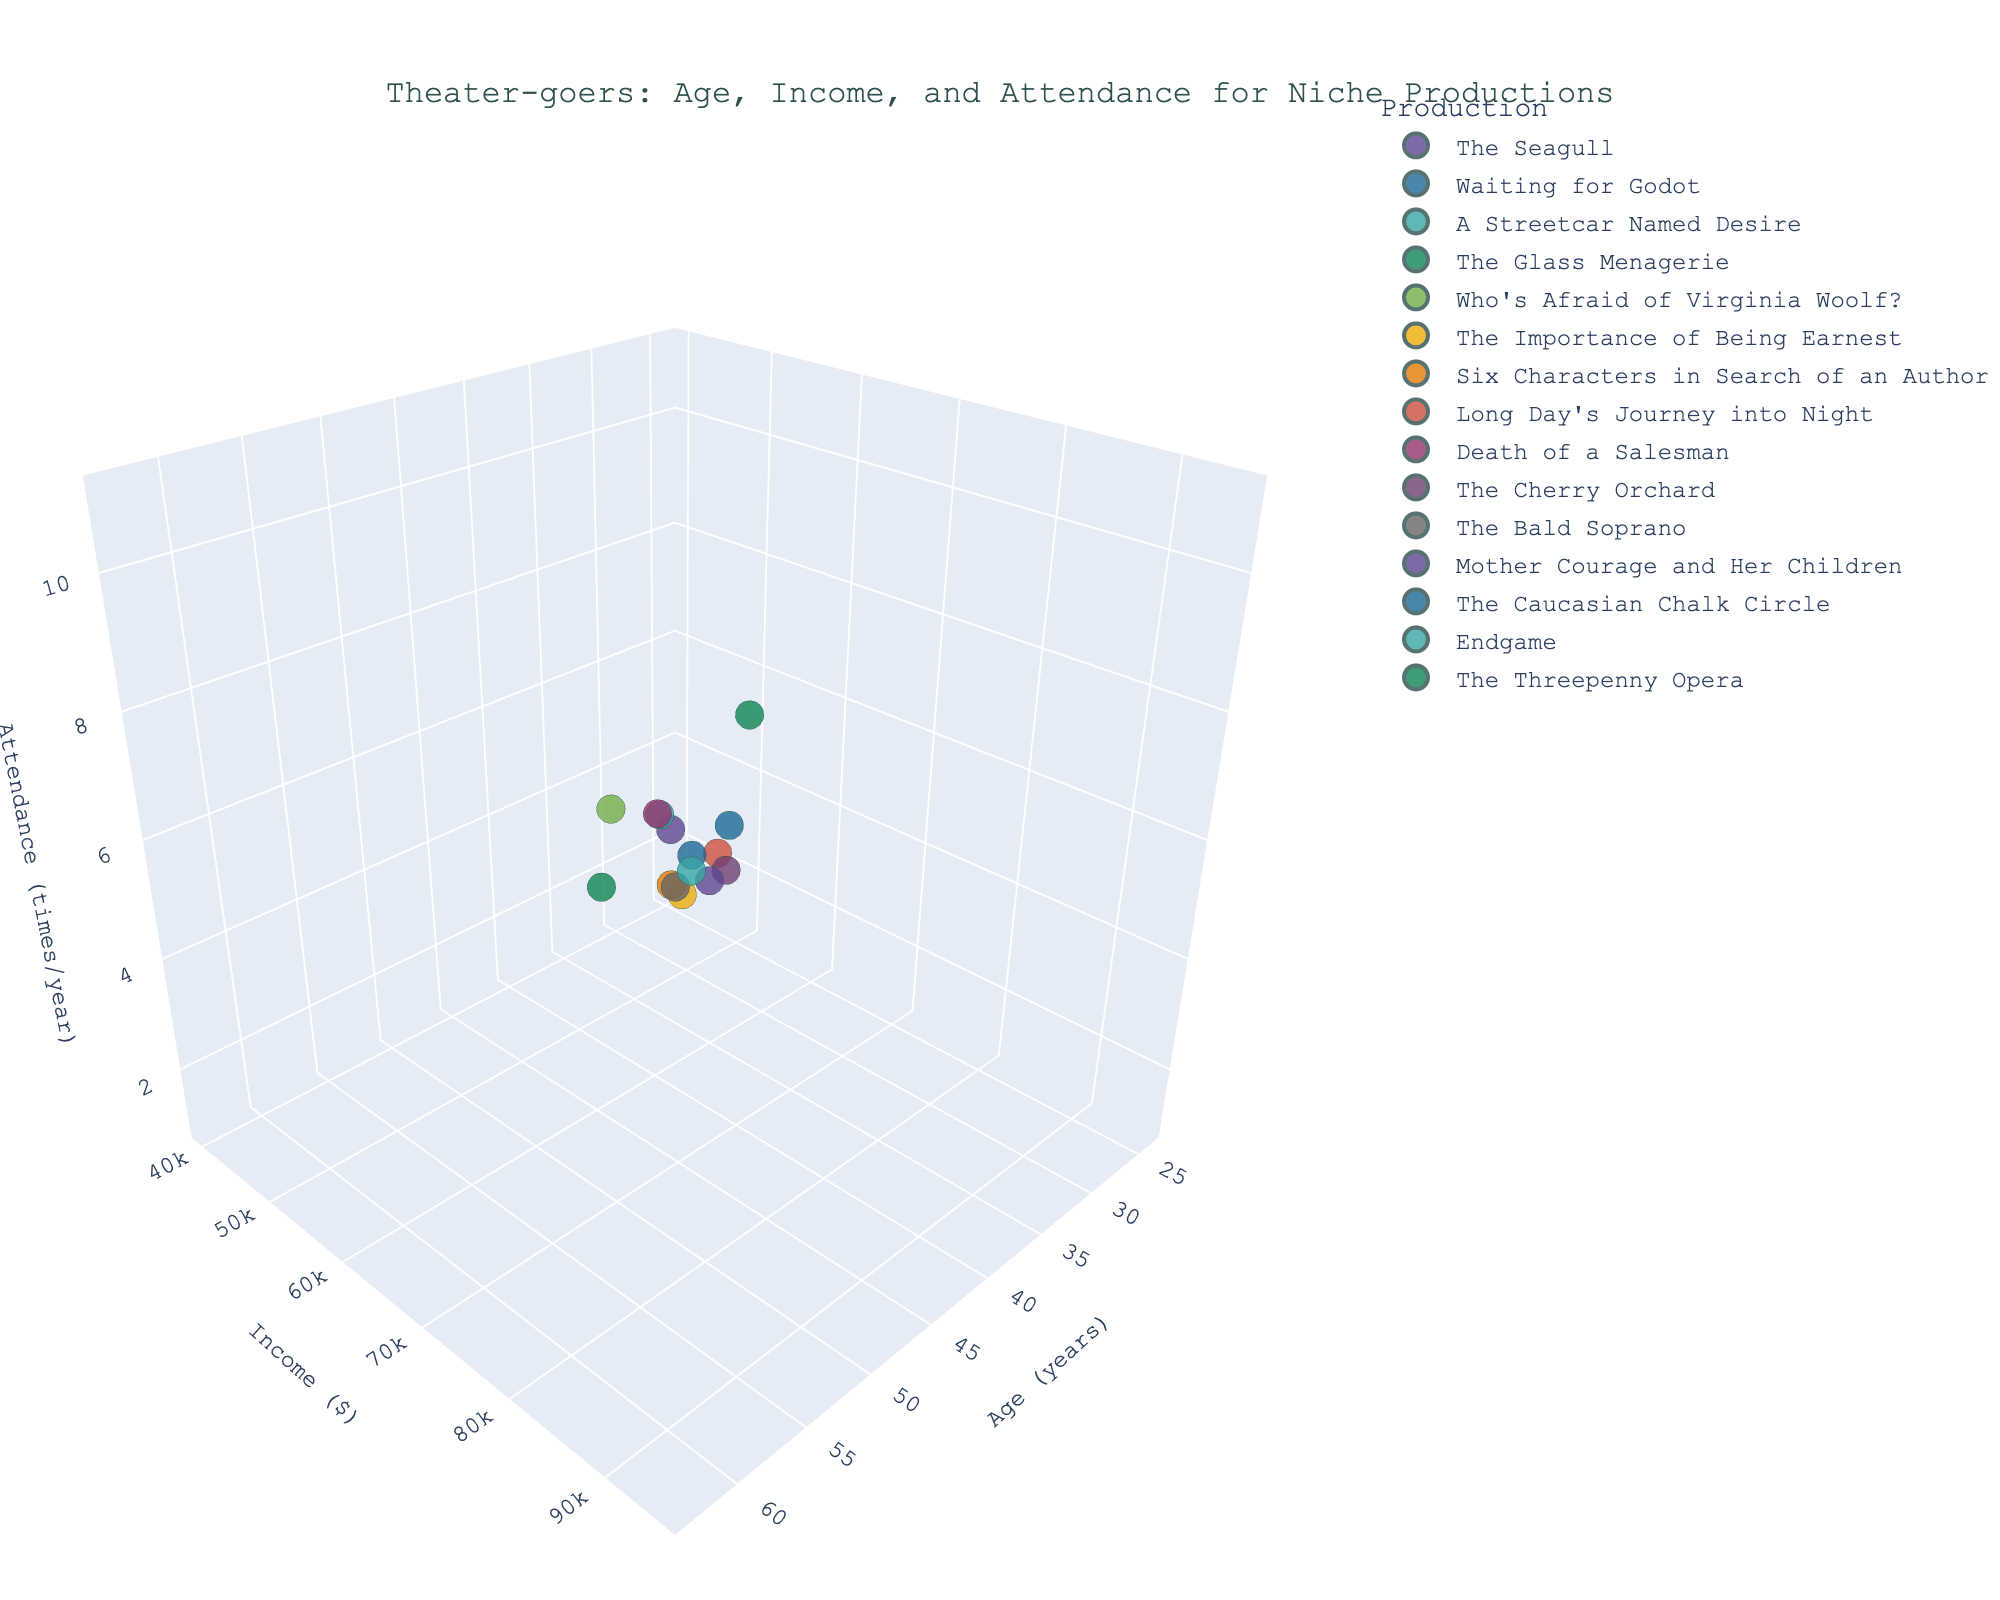How many productions are represented in the figure? By examining the figure legend and counting the unique color-coded productions, we can determine how many different productions are represented.
Answer: 15 What is the income range of theater-goers attending "Death of a Salesman"? Identify the data point for "Death of a Salesman" by its unique color in the legend and locate its position on the Y-axis representing income.
Answer: $85,000 What is the average attendance for theater-goers aged 50 and above? Identify the data points for theater-goers aged 50 and above, then sum their attendance values and divide by the number of these data points to find the average.
Answer: 8.2 Which production has the highest attendance? Locate the data point with the highest value on the Z-axis (attendance) and identify the corresponding production from the legend or hover data.
Answer: "The Threepenny Opera" Compare the average income of theater-goers attending "The Seagull" and "Endgame". Which one is higher? Identify and note the income values for both productions, then compare them to determine which is higher.
Answer: "Endgame" at $52,000 What is the highest income level among theater-goers? Examine the Y-axis to identify the highest data point, representing the maximum income level.
Answer: $95,000 Is there any noticeable trend between age and frequency of attendance? Look at the scatter of data points along the X-axis (age) and Z-axis (attendance) to identify any patterns or trends.
Answer: Older theater-goers tend to attend more frequently What is the difference in attendance between "Six Characters in Search of an Author" and "A Streetcar Named Desire"? Find and note the attendance values for these two productions by their respective data points and subtract them.
Answer: 2 For theater-goers with an income of $70,000, how many different productions did they attend? Locate the data points at the $70,000 income level and count the unique productions represented by these points.
Answer: 1 Which production attracts the youngest audience on average? Identify and list the ages of attendees for each production, calculate the average age for each, and identify the production with the lowest average age.
Answer: "The Bald Soprano" 